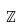Convert formula to latex. <formula><loc_0><loc_0><loc_500><loc_500>\mathbb { Z }</formula> 